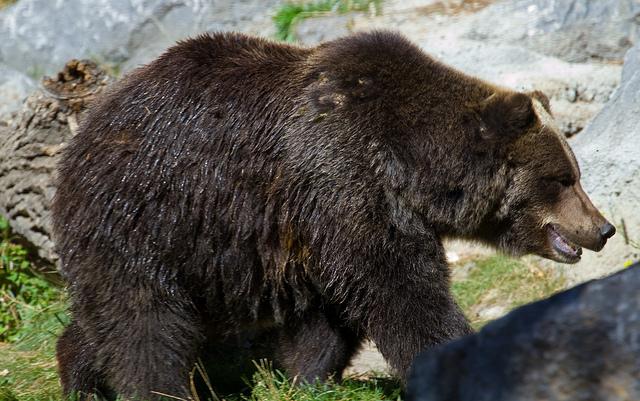What color is the bear's nose?
Write a very short answer. Black. What color is the bear?
Answer briefly. Brown. What color are the bears?
Be succinct. Brown. What color is this bear?
Give a very brief answer. Brown. How big do you think the bear is?
Short answer required. Very big. What species of bear is this?
Give a very brief answer. Brown. Is the bear hungry?
Give a very brief answer. No. Is the bear's mouth open?
Be succinct. Yes. What kind of bear is this?
Write a very short answer. Brown. 